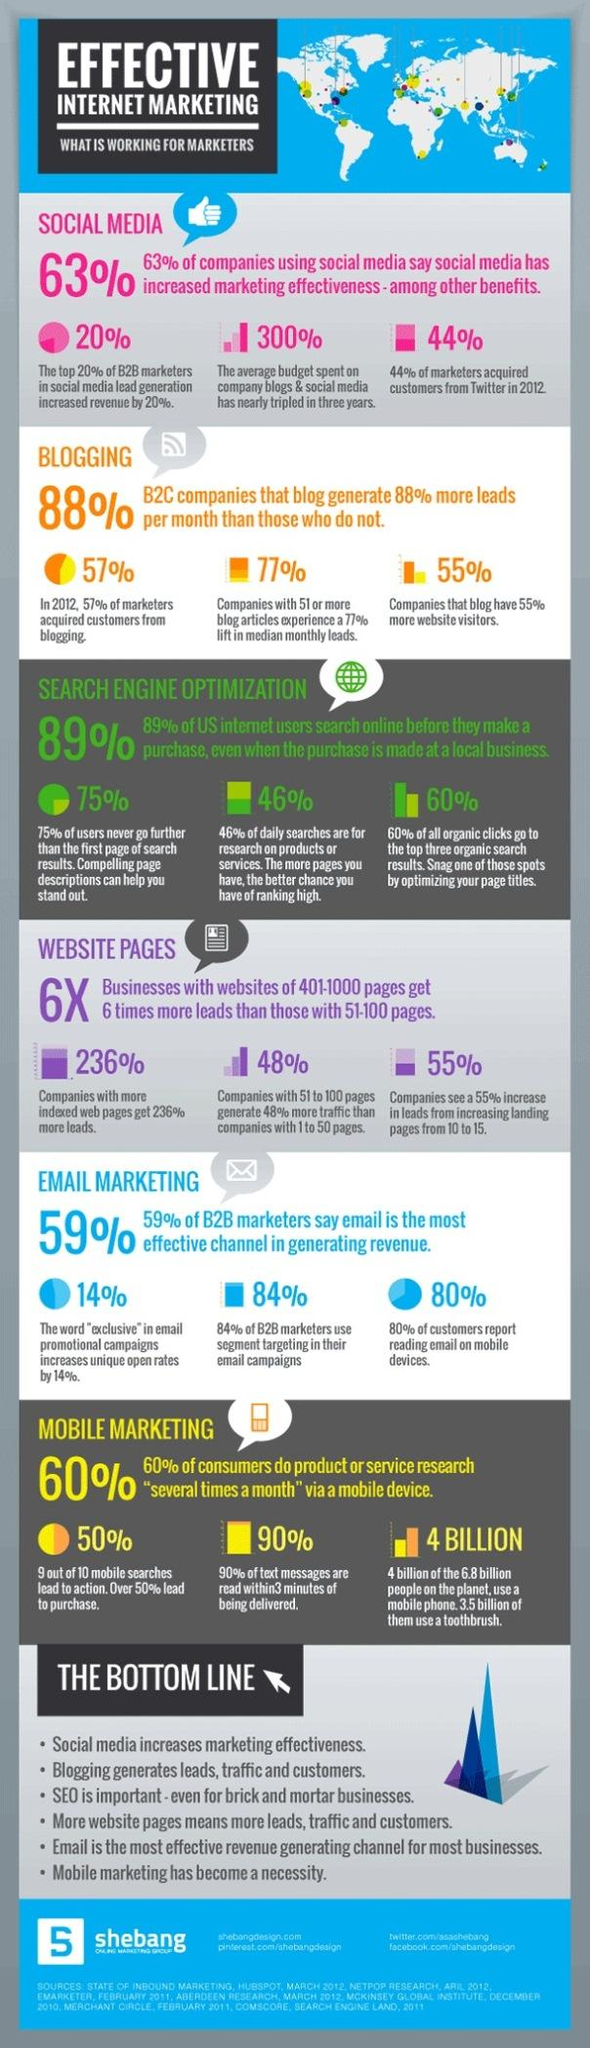List a handful of essential elements in this visual. According to data, the percentage of new customers obtained through blogging is 57%, 55%, or 88%. A survey found that 59% of marketers believe that sending business emails can help channelize revenue. According to a survey, 60% of people mostly click on the top most results displayed in the search engine. The lead generated through social media has resulted in a rise in income of 63%, 20%, or 44%, depending on the specific scenario. 